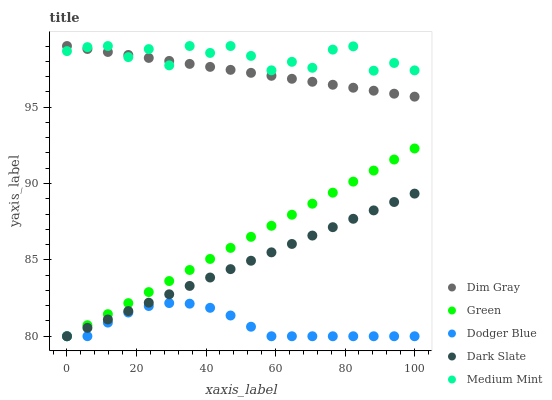Does Dodger Blue have the minimum area under the curve?
Answer yes or no. Yes. Does Medium Mint have the maximum area under the curve?
Answer yes or no. Yes. Does Dim Gray have the minimum area under the curve?
Answer yes or no. No. Does Dim Gray have the maximum area under the curve?
Answer yes or no. No. Is Green the smoothest?
Answer yes or no. Yes. Is Medium Mint the roughest?
Answer yes or no. Yes. Is Dodger Blue the smoothest?
Answer yes or no. No. Is Dodger Blue the roughest?
Answer yes or no. No. Does Dodger Blue have the lowest value?
Answer yes or no. Yes. Does Dim Gray have the lowest value?
Answer yes or no. No. Does Dim Gray have the highest value?
Answer yes or no. Yes. Does Dodger Blue have the highest value?
Answer yes or no. No. Is Green less than Medium Mint?
Answer yes or no. Yes. Is Medium Mint greater than Green?
Answer yes or no. Yes. Does Green intersect Dark Slate?
Answer yes or no. Yes. Is Green less than Dark Slate?
Answer yes or no. No. Is Green greater than Dark Slate?
Answer yes or no. No. Does Green intersect Medium Mint?
Answer yes or no. No. 